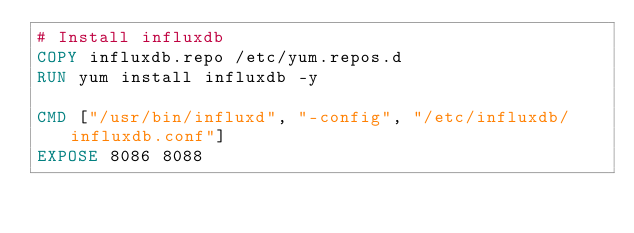Convert code to text. <code><loc_0><loc_0><loc_500><loc_500><_Dockerfile_># Install influxdb
COPY influxdb.repo /etc/yum.repos.d
RUN yum install influxdb -y

CMD ["/usr/bin/influxd", "-config", "/etc/influxdb/influxdb.conf"]
EXPOSE 8086 8088
</code> 